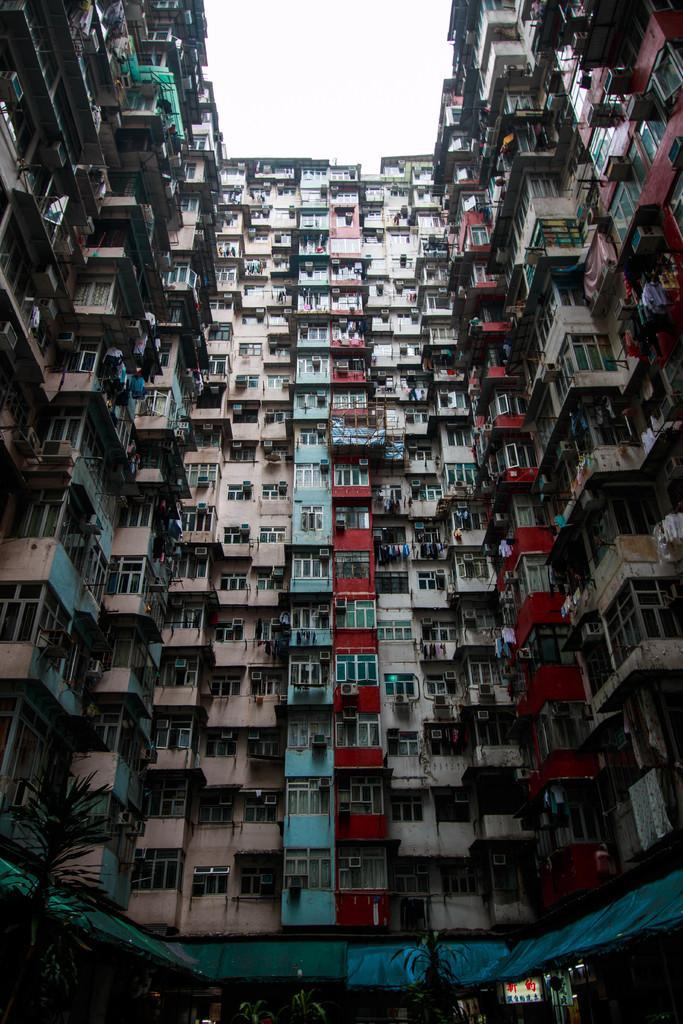Please provide a concise description of this image. This image consists of building with windows in the foreground. It looks like a shed and there are potted plants at the bottom. 